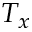<formula> <loc_0><loc_0><loc_500><loc_500>T _ { x }</formula> 